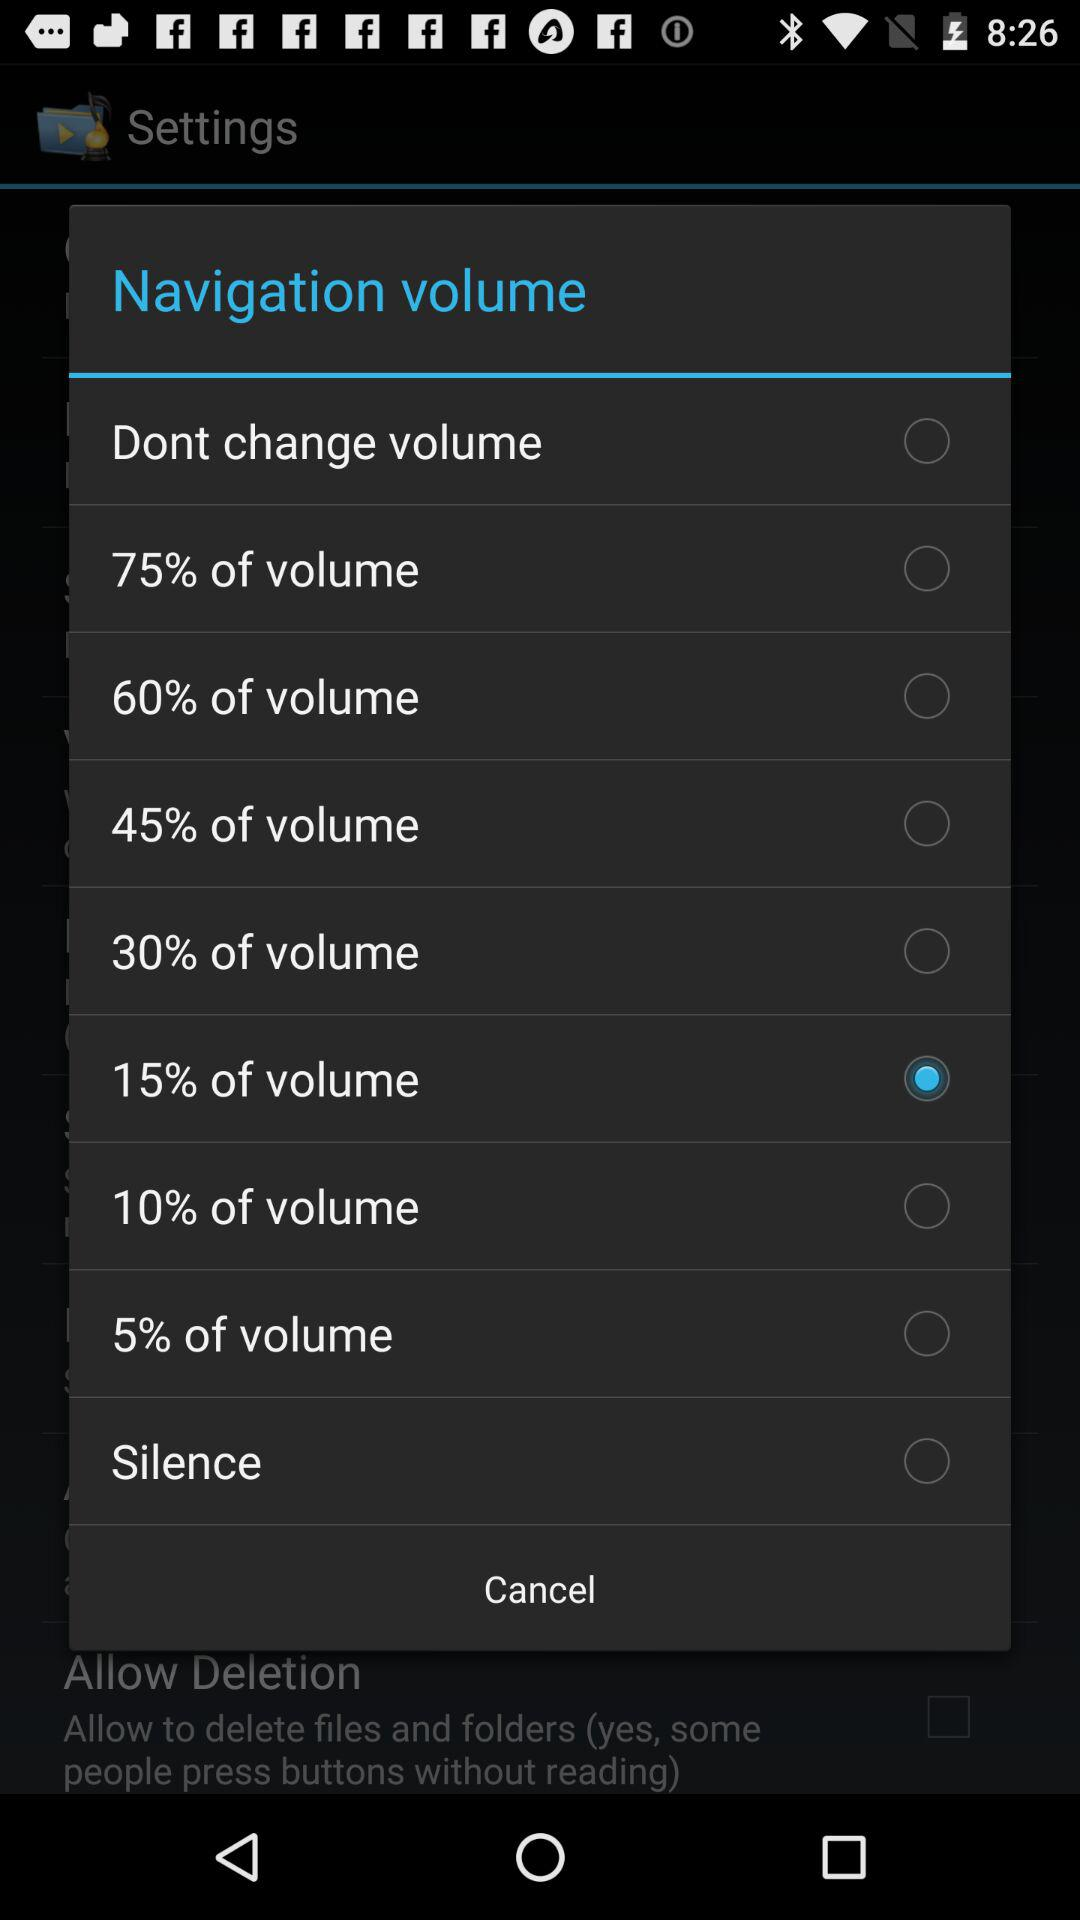Which option is checked? The checked option is "15% of volume". 